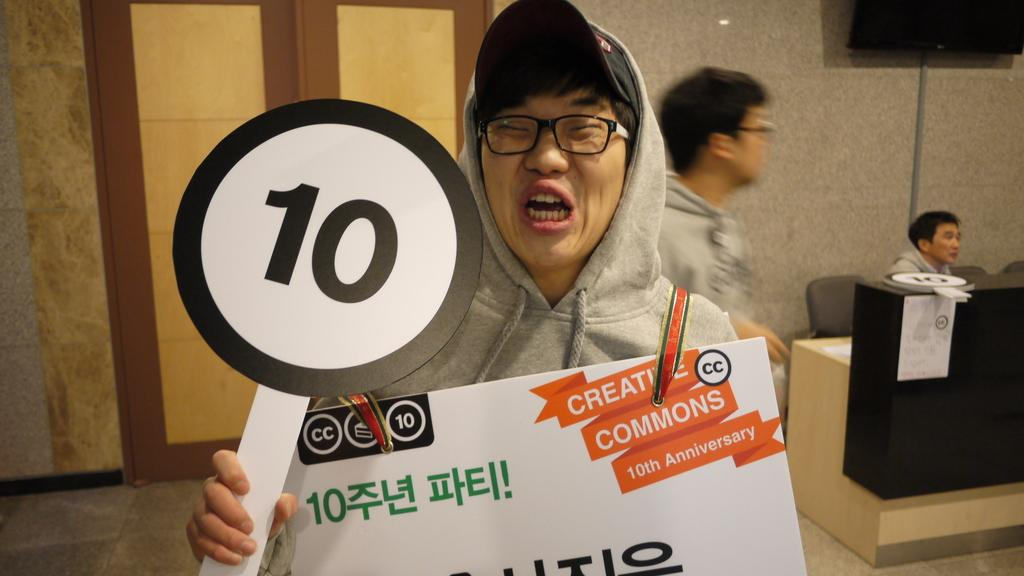What is the man in the image doing with the placard? The man in the image is holding a placard. How is the man with the placard expressing himself? The man is shouting. What is the man wearing in the image? The man is wearing an ash-colored sweater. Can you describe the other person in the image? There is another man sitting on a chair on the right side of the image. What type of pancake is the man flipping in the image? There is no pancake present in the image; the man is holding a placard and shouting. 